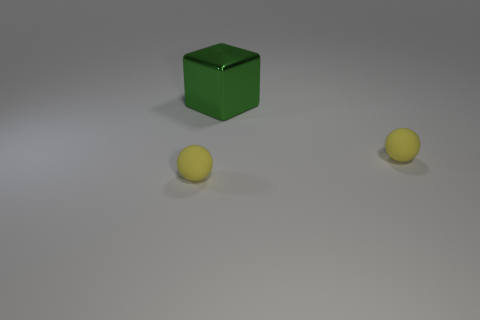How many yellow balls must be subtracted to get 1 yellow balls? 1 Add 1 green objects. How many objects exist? 4 Subtract all blocks. How many objects are left? 2 Add 1 tiny yellow spheres. How many tiny yellow spheres are left? 3 Add 3 yellow rubber things. How many yellow rubber things exist? 5 Subtract 0 green cylinders. How many objects are left? 3 Subtract all large yellow rubber spheres. Subtract all spheres. How many objects are left? 1 